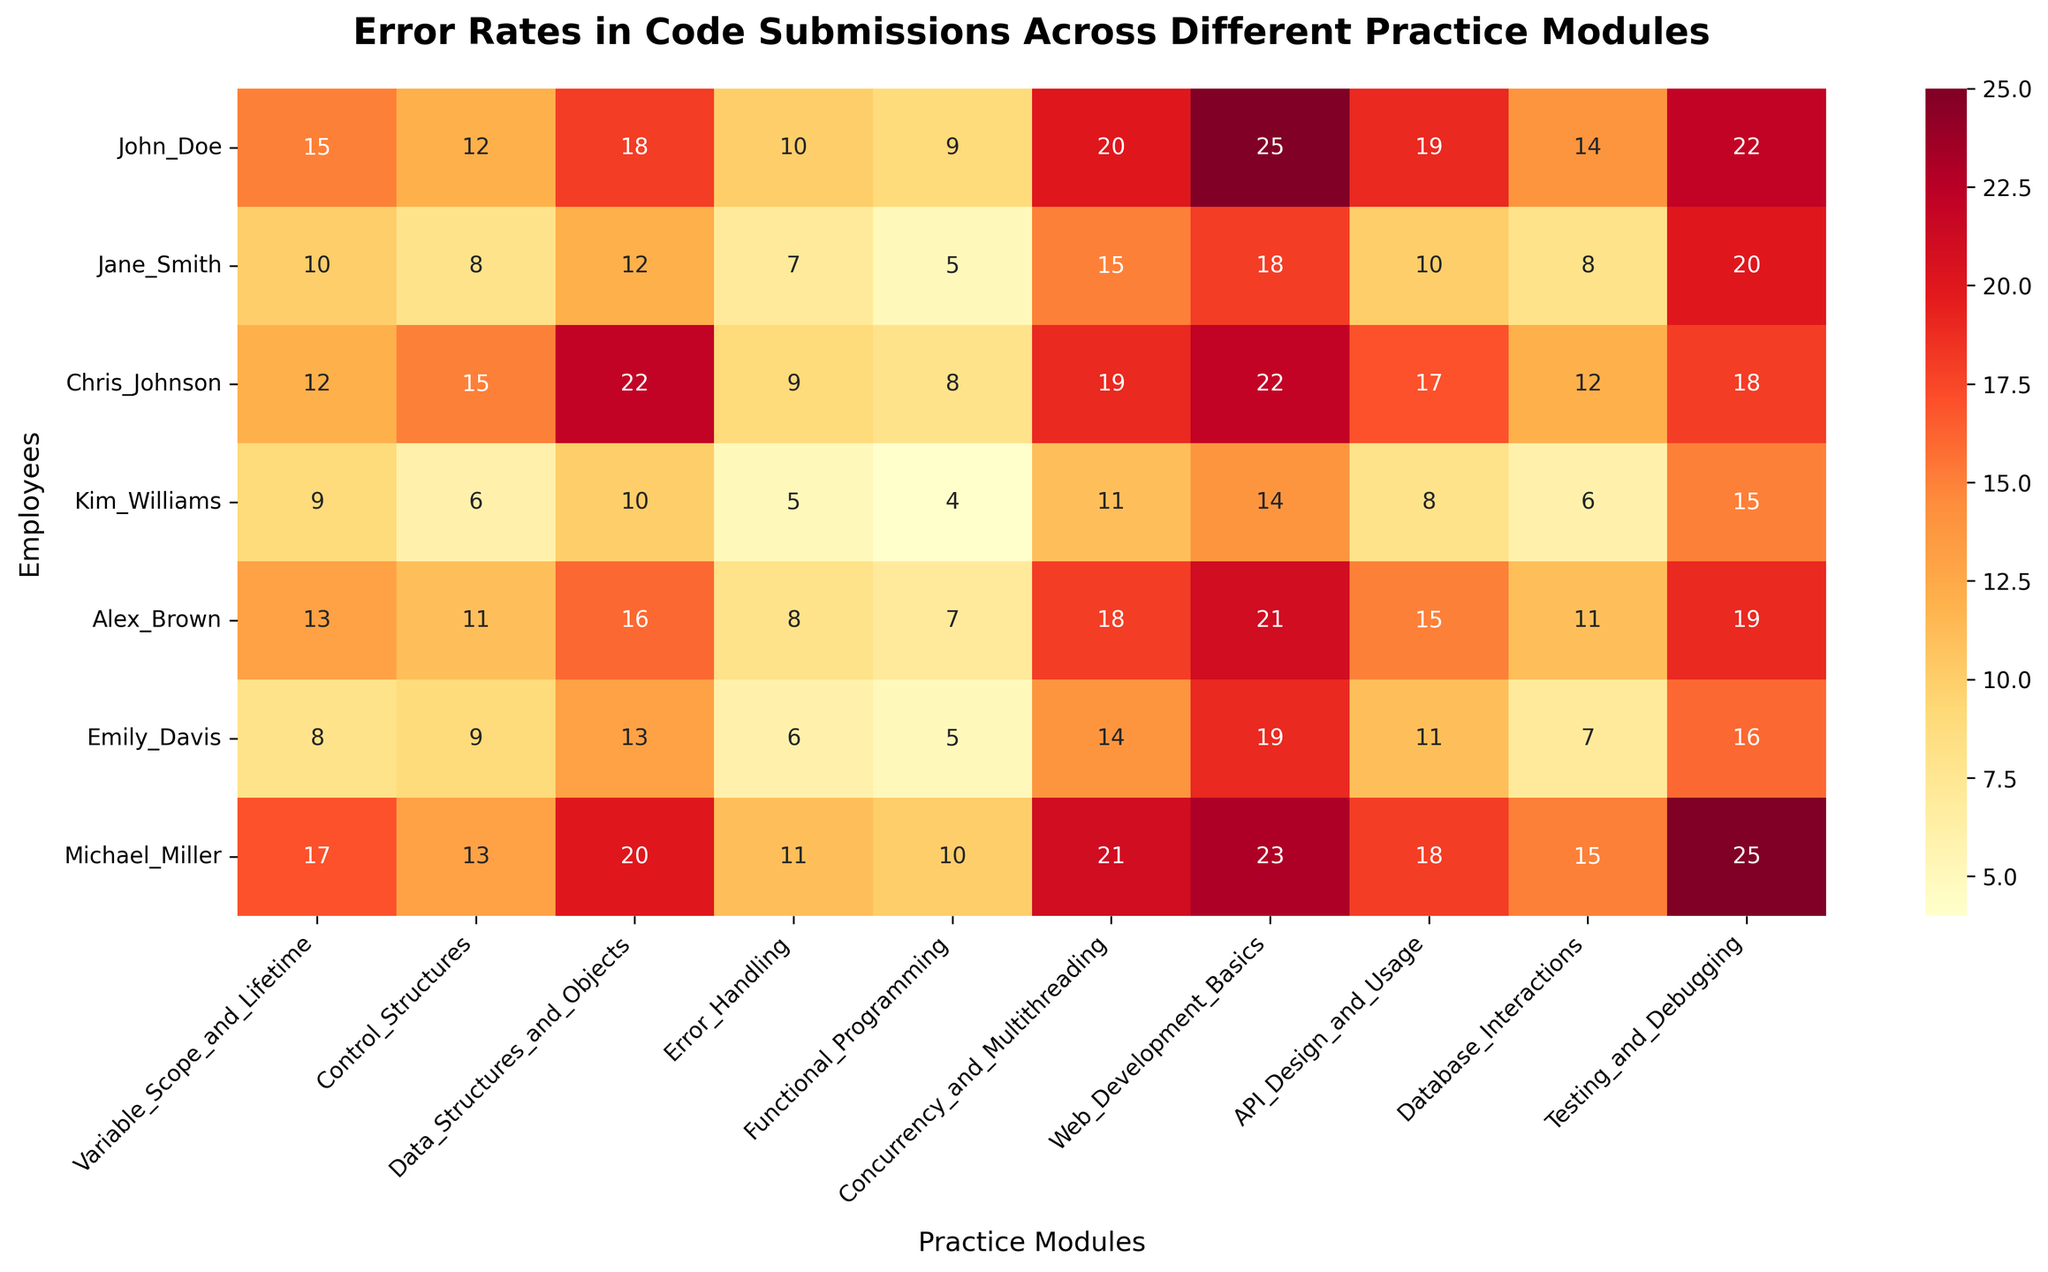What is the title of the figure? The title of the figure is displayed prominently at the top. It reads "Error Rates in Code Submissions Across Different Practice Modules."
Answer: Error Rates in Code Submissions Across Different Practice Modules Which employee has the highest error rate in the Concurrency and Multithreading module? Look at the column for "Concurrency and Multithreading" and identify which row has the highest value. Michael Miller has the highest value of 21.
Answer: Michael Miller How many errors did Emily Davis make in the Testing and Debugging module? Locate Emily Davis in the y-axis (rows) and then find the corresponding error rate in the "Testing and Debugging" column. The value is 16.
Answer: 16 Which two employees have the exact same error rate in the Error Handling module? Observe the Error Handling column and find any two identical values. Both Jane Smith and Kim Williams have an error rate of 5 in the Error Handling module.
Answer: Jane Smith and Kim Williams What is the average error rate for Alex Brown across all modules? Sum up all error rates for Alex Brown: \(13 + 11 + 16 + 8 + 7 + 18 + 21 + 15 + 11 + 19 = 139\). Divide by the number of modules (10): \(139 / 10 = 13.9\).
Answer: 13.9 What is the difference in error rates between John Doe and Jane Smith in the API Design and Usage module? Find the error rates for both John Doe and Jane Smith in the "API Design and Usage" column. Subtract Jane Smith's 10 from John Doe's 19: \(19 - 10 = 9\).
Answer: 9 Which module has the highest average error rate? Calculate the average error rate for each module by summing all the employee error rates and dividing by the number of employees, and then compare the averages. The module "Web Development Basics" has the highest average: \((25 + 18 + 22 + 14 + 21 + 19 + 23) / 7 = 20.29\).
Answer: Web Development Basics How does Chris Johnson's error rate in Database Interactions compare to Kim Williams'? Find their error rates in the "Database Interactions" column. Chris Johnson's error rate is 12, and Kim Williams' is 6, so Chris Johnson's rate is higher.
Answer: Chris Johnson's is higher What is the median error rate for Functional Programming? List all error rates in the Functional Programming column: \(9, 5, 8, 4, 7, 5, 10\). Sort these values: \(4, 5, 5, 7, 8, 9, 10\). The median is the middle value: 7.
Answer: 7 